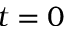Convert formula to latex. <formula><loc_0><loc_0><loc_500><loc_500>t = 0</formula> 